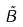<formula> <loc_0><loc_0><loc_500><loc_500>\tilde { B }</formula> 